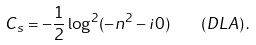<formula> <loc_0><loc_0><loc_500><loc_500>C _ { s } = - \frac { 1 } { 2 } \log ^ { 2 } ( - n ^ { 2 } - i 0 ) \quad \left ( D L A \right ) .</formula> 